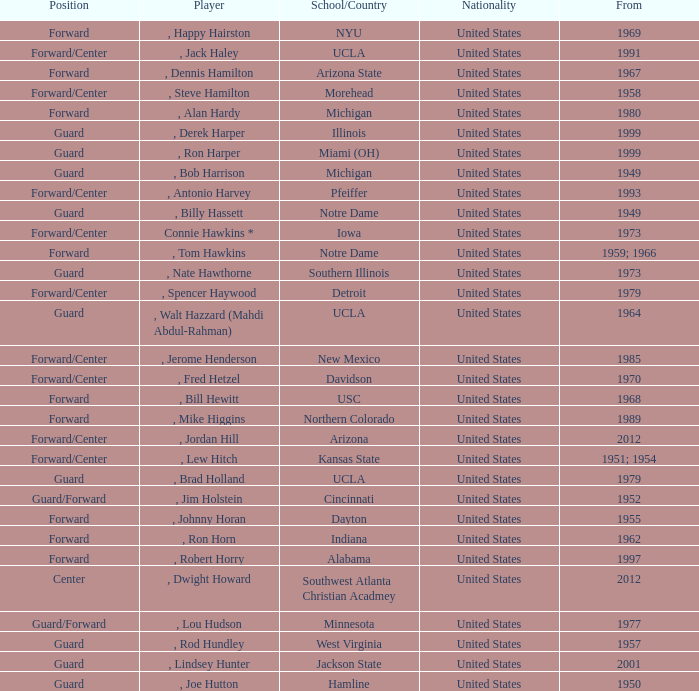Which player started in 2001? , Lindsey Hunter. 